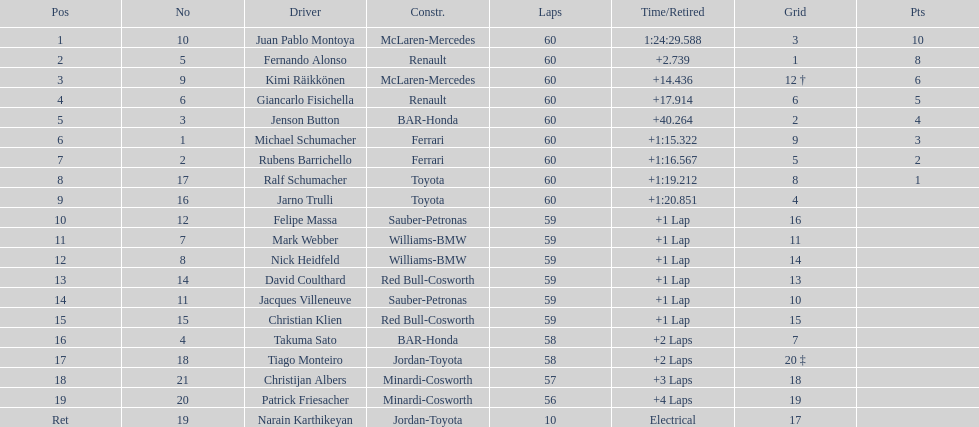Out of all drivers, who has earned the fewest points? Ralf Schumacher. Would you mind parsing the complete table? {'header': ['Pos', 'No', 'Driver', 'Constr.', 'Laps', 'Time/Retired', 'Grid', 'Pts'], 'rows': [['1', '10', 'Juan Pablo Montoya', 'McLaren-Mercedes', '60', '1:24:29.588', '3', '10'], ['2', '5', 'Fernando Alonso', 'Renault', '60', '+2.739', '1', '8'], ['3', '9', 'Kimi Räikkönen', 'McLaren-Mercedes', '60', '+14.436', '12 †', '6'], ['4', '6', 'Giancarlo Fisichella', 'Renault', '60', '+17.914', '6', '5'], ['5', '3', 'Jenson Button', 'BAR-Honda', '60', '+40.264', '2', '4'], ['6', '1', 'Michael Schumacher', 'Ferrari', '60', '+1:15.322', '9', '3'], ['7', '2', 'Rubens Barrichello', 'Ferrari', '60', '+1:16.567', '5', '2'], ['8', '17', 'Ralf Schumacher', 'Toyota', '60', '+1:19.212', '8', '1'], ['9', '16', 'Jarno Trulli', 'Toyota', '60', '+1:20.851', '4', ''], ['10', '12', 'Felipe Massa', 'Sauber-Petronas', '59', '+1 Lap', '16', ''], ['11', '7', 'Mark Webber', 'Williams-BMW', '59', '+1 Lap', '11', ''], ['12', '8', 'Nick Heidfeld', 'Williams-BMW', '59', '+1 Lap', '14', ''], ['13', '14', 'David Coulthard', 'Red Bull-Cosworth', '59', '+1 Lap', '13', ''], ['14', '11', 'Jacques Villeneuve', 'Sauber-Petronas', '59', '+1 Lap', '10', ''], ['15', '15', 'Christian Klien', 'Red Bull-Cosworth', '59', '+1 Lap', '15', ''], ['16', '4', 'Takuma Sato', 'BAR-Honda', '58', '+2 Laps', '7', ''], ['17', '18', 'Tiago Monteiro', 'Jordan-Toyota', '58', '+2 Laps', '20 ‡', ''], ['18', '21', 'Christijan Albers', 'Minardi-Cosworth', '57', '+3 Laps', '18', ''], ['19', '20', 'Patrick Friesacher', 'Minardi-Cosworth', '56', '+4 Laps', '19', ''], ['Ret', '19', 'Narain Karthikeyan', 'Jordan-Toyota', '10', 'Electrical', '17', '']]} 